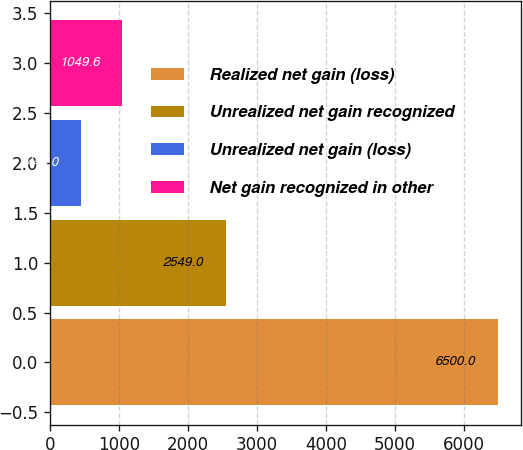Convert chart. <chart><loc_0><loc_0><loc_500><loc_500><bar_chart><fcel>Realized net gain (loss)<fcel>Unrealized net gain recognized<fcel>Unrealized net gain (loss)<fcel>Net gain recognized in other<nl><fcel>6500<fcel>2549<fcel>444<fcel>1049.6<nl></chart> 